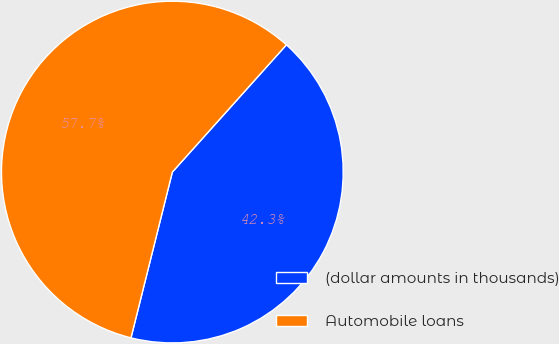Convert chart to OTSL. <chart><loc_0><loc_0><loc_500><loc_500><pie_chart><fcel>(dollar amounts in thousands)<fcel>Automobile loans<nl><fcel>42.26%<fcel>57.74%<nl></chart> 